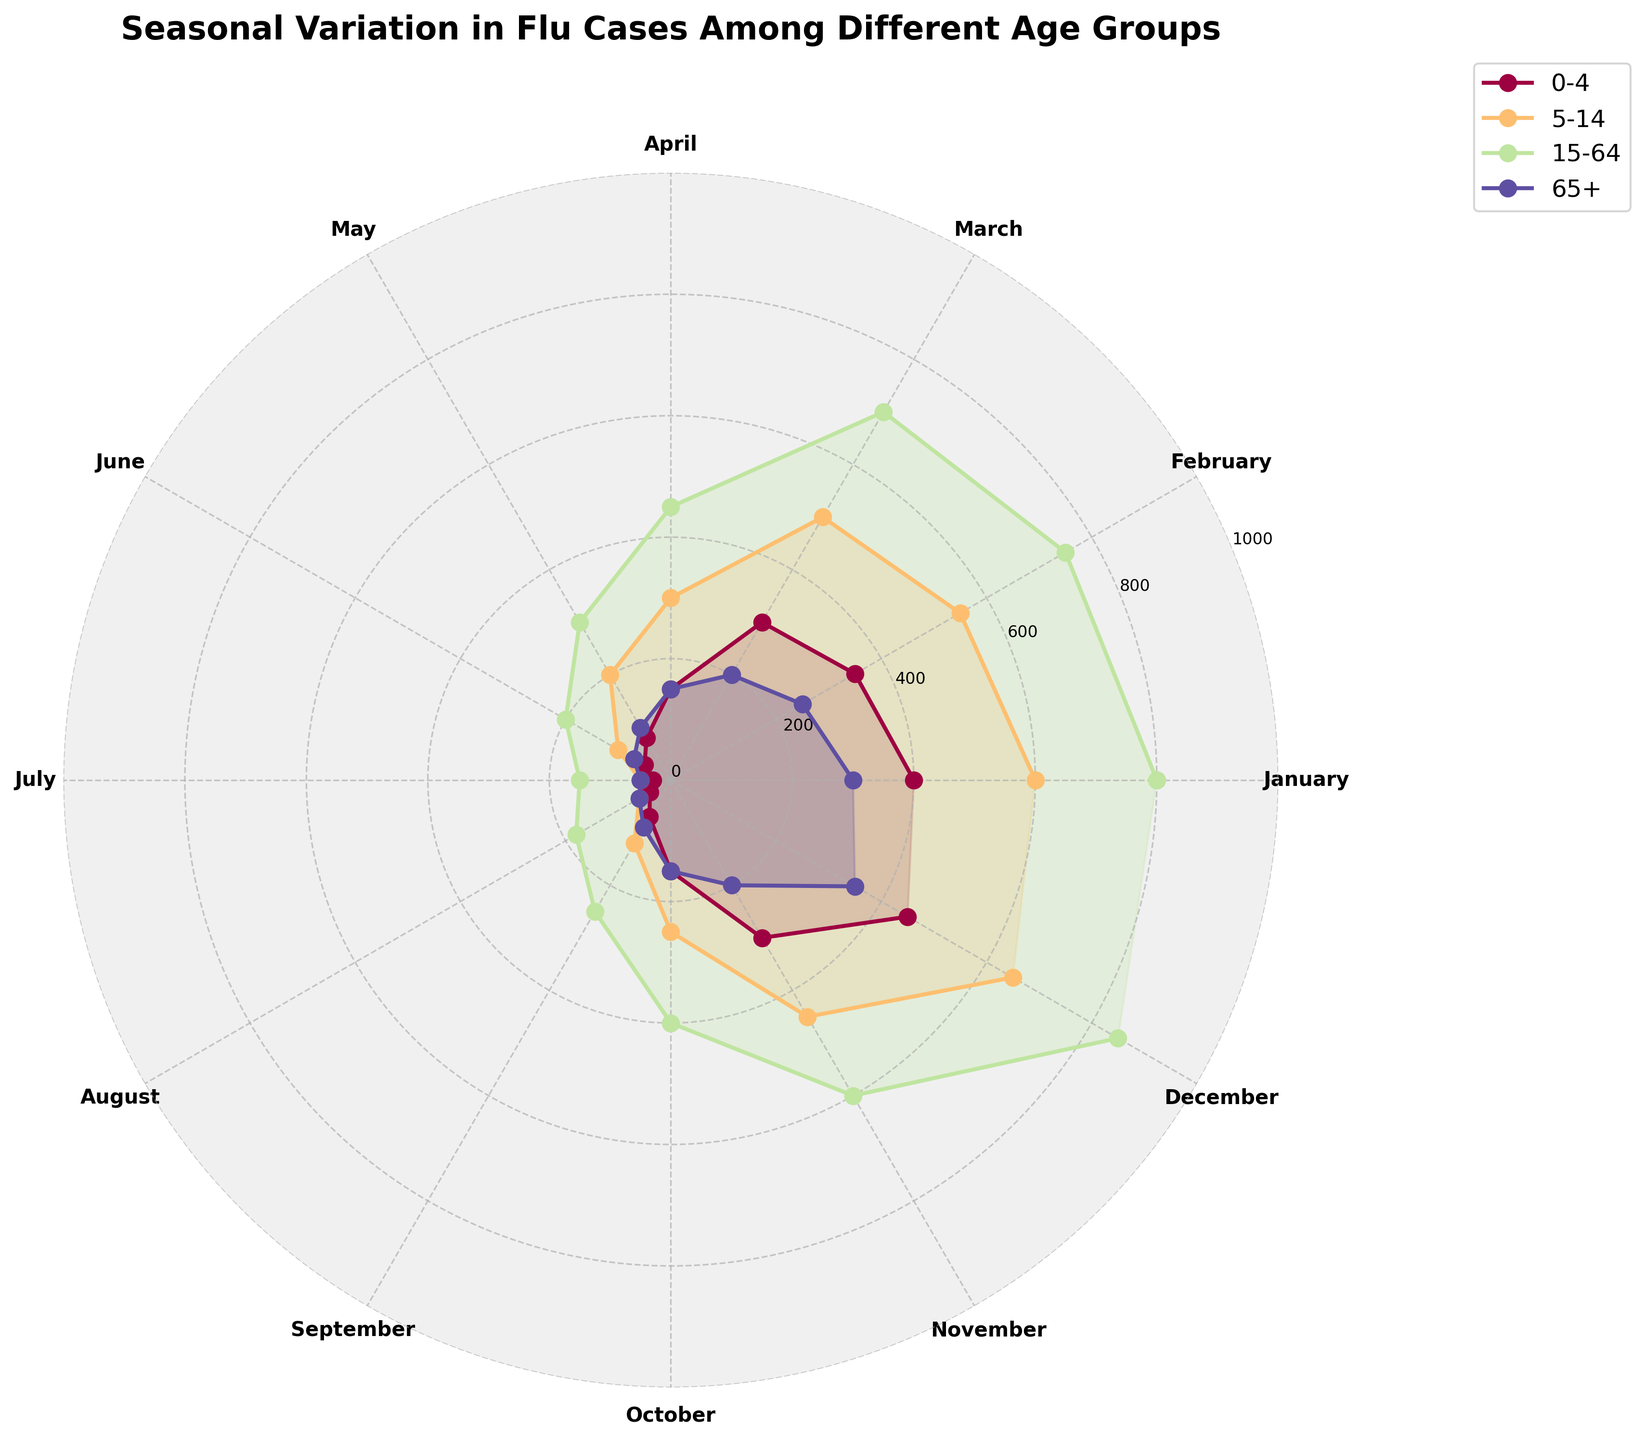How many age groups are represented in the plot? There are four age groups represented in the plot. This can be determined by the legend which includes four different labels indicating the age groups: '0-4', '5-14', '15-64', and '65+'.
Answer: Four Which month has the highest number of flu cases for the age group 15-64? To determine this, look at the plot and find where the values for the age group 15-64 (represented by one of the lines and its corresponding color) peak. The highest value occurs in December.
Answer: December Compare the number of flu cases between the age groups 0-4 and 65+ in January. Which has more cases, and by how much? Look at the plot to find the values for January for these two age groups. The age group 0-4 has 400 cases, and the age group 65+ has 300 cases. 400 - 300 = 100, so the age group 0-4 has 100 more cases.
Answer: 0-4 by 100 cases What is the overall trend of flu cases throughout the year for the age group 5-14? By observing the plotted values for the age group 5-14, we see that flu cases start high in January, gradually decrease, reaching a low around July, and then increase again towards December.
Answer: Decreases then increases In which months do all age groups show a notable decrease in flu cases, and when do they start to increase again? By examining the plotted lines for all age groups, flu cases for all groups decrease from January through July. They start to show an increase around September.
Answer: Decrease: Jan-Jul, Increase: Sep For the age group 15-64, which months show the maximum and minimum flu cases? By observing the plot, the maximum flu cases for the age group 15-64 occur in December and the minimum in July.
Answer: Max: December, Min: July How does the seasonal variation in flu cases for the age group 65+ compare to those aged 0-4? The flu cases for both age groups peak around the winter months (December and January) and are lowest in the summer months (July and August). The variation is similar in pattern but different in magnitude.
Answer: Similar pattern, different magnitude Which age group shows the highest increase in flu cases from November to December? Observe all age groups' values for these two months. The age group 15-64 increases from 600 in November to 850 in December, the highest compared to other age groups.
Answer: 15-64 During which month do the age groups 0-4 and 5-14 have the same number of flu cases? Check the plotted values for both age groups across all months. In April, both the age groups 0-4 and 5-14 have 150 flu cases each.
Answer: April 